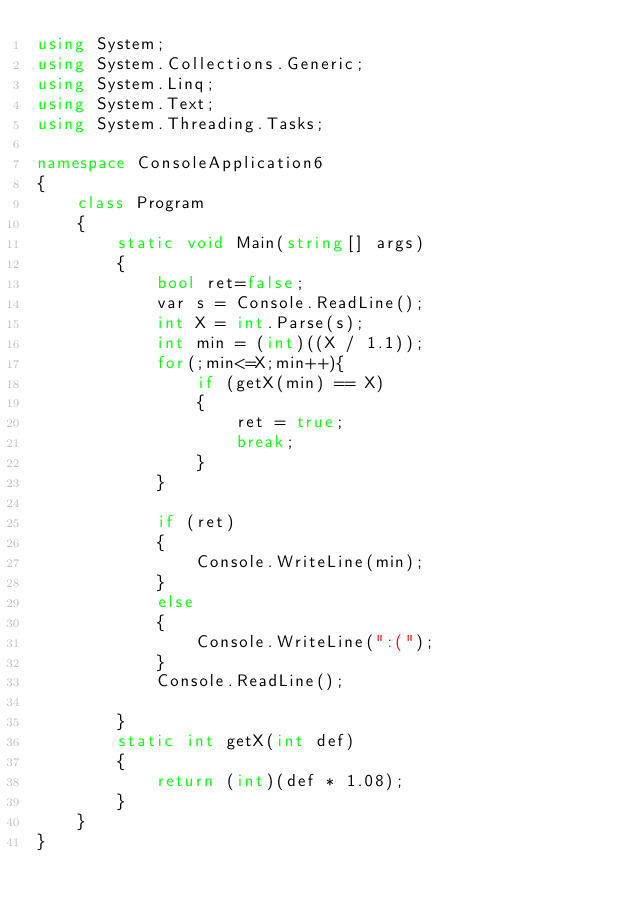<code> <loc_0><loc_0><loc_500><loc_500><_C#_>using System;
using System.Collections.Generic;
using System.Linq;
using System.Text;
using System.Threading.Tasks;

namespace ConsoleApplication6
{
    class Program
    {
        static void Main(string[] args)
        {
            bool ret=false;
            var s = Console.ReadLine();
            int X = int.Parse(s);
            int min = (int)((X / 1.1));
            for(;min<=X;min++){
                if (getX(min) == X)
                {
                    ret = true;
                    break;
                }
            }

            if (ret)
            {
                Console.WriteLine(min);
            }
            else
            {
                Console.WriteLine(":(");
            }
            Console.ReadLine();

        }
        static int getX(int def)
        {
            return (int)(def * 1.08);
        }
    }
}
</code> 